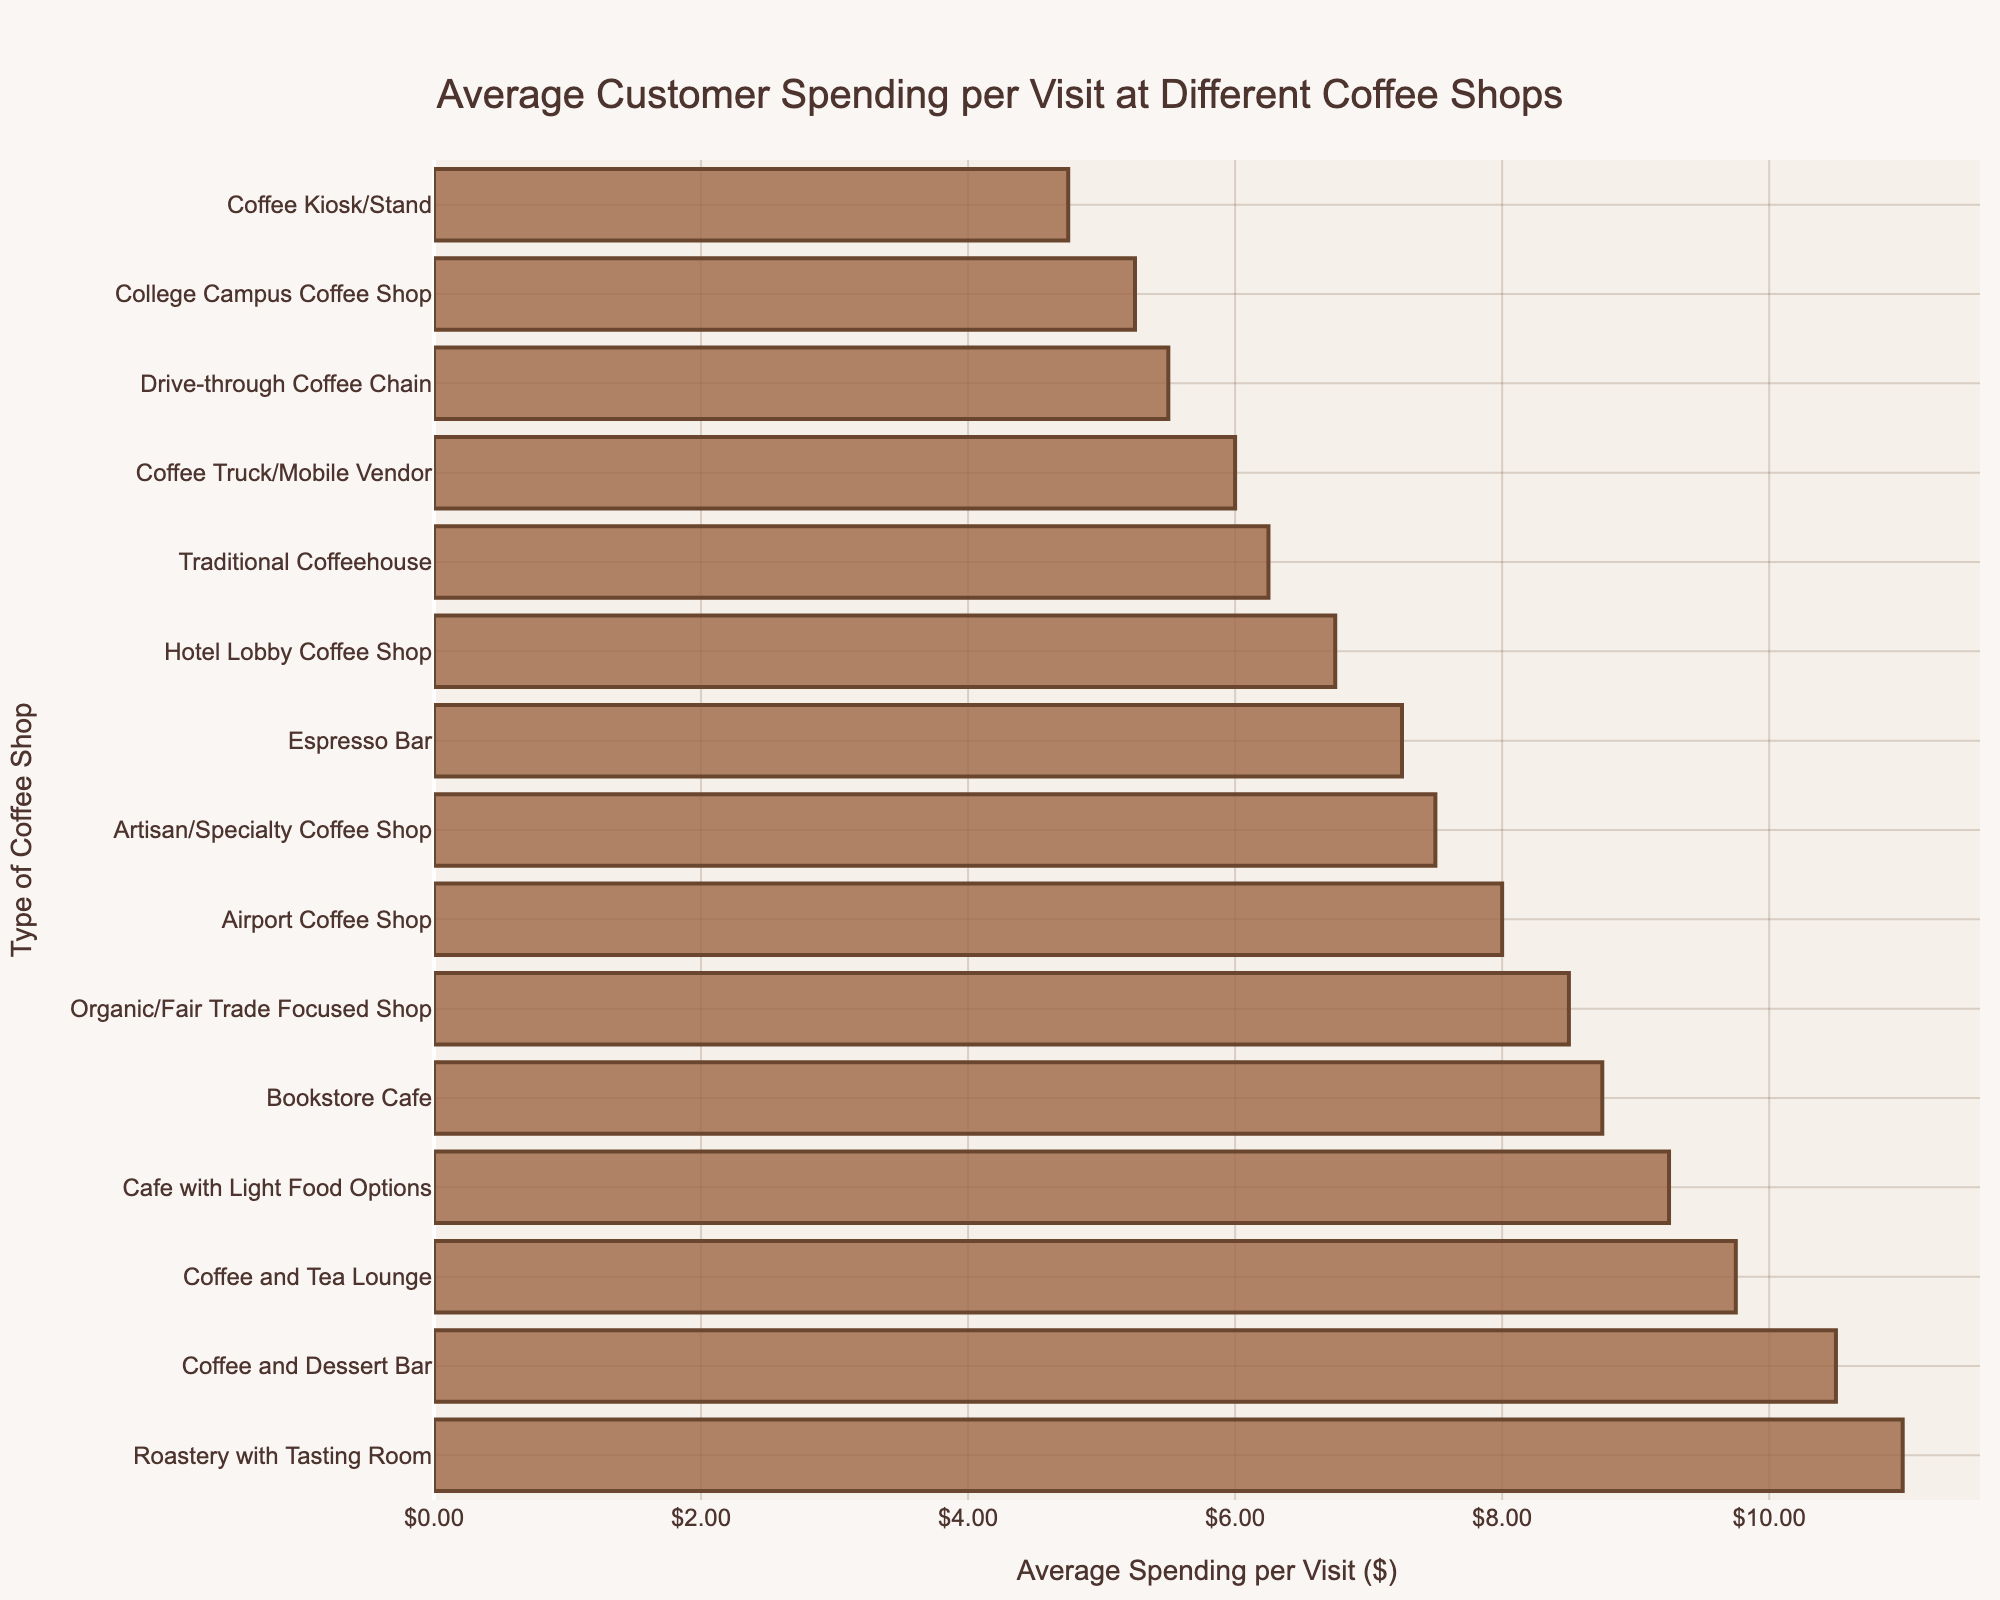What's the highest average customer spending per visit and at which type of coffee shop? The highest average spending per visit is $11.00 at a roastery with a tasting room. This is determined by looking at the bar with the longest length.
Answer: $11.00, Roastery with Tasting Room Which type of coffee shop has the lowest average customer spending per visit and what is the amount? The coffee kiosk/stand has the lowest average customer spending per visit at $4.75, which is identified by the shortest bar.
Answer: $4.75, Coffee Kiosk/Stand How much more does a customer spend on average at a coffee and dessert bar compared to a traditional coffeehouse? The average spending at a coffee and dessert bar is $10.50, while at a traditional coffeehouse it is $6.25. The difference is $10.50 - $6.25 = $4.25.
Answer: $4.25 What is the combined average spending of customers visiting the top three types of coffee shops? The top three types of coffee shops are roastery with tasting room ($11.00), coffee and dessert bar ($10.50), and coffee and tea lounge ($9.75). Their combined average spending is $11.00 + $10.50 + $9.75 = $31.25.
Answer: $31.25 Which coffee shop type has average spending closest to $8.00 and what is that spending? The airport coffee shop has an average spending of $8.00, as indicated by the bar that aligns exactly with the $8.00 mark on the x-axis.
Answer: $8.00, Airport Coffee Shop By how much does average spending at a college campus coffee shop differ from an organic/fair trade focused shop? The average spending at a college campus coffee shop is $5.25 and at an organic/fair trade focused shop is $8.50. The difference is $8.50 - $5.25 = $3.25.
Answer: $3.25 What is the median average customer spending per visit among all coffee shop types? To find the median, list all the spending values in ascending order and find the middle value or average the two middle values. The middle value in a list of 15 values is the 8th value. The sorted values are $4.75, $5.25, $5.50, $6.00, $6.25, $6.75, $7.25, $7.50, $8.00, $8.50, $8.75, $9.25, $9.75, $10.50, $11.00. The 8th value is $7.50.
Answer: $7.50 Which coffee shop types have average spending higher than the median value and what are those average spendings? The median average spending is $7.50. The coffee shop types with higher average spending are cafe with light food options ($9.25), bookstore cafe ($8.75), organic/fair trade focused shop ($8.50), coffee and dessert bar ($10.50), roastery with tasting room ($11.00), coffee and tea lounge ($9.75), airport coffee shop ($8.00).
Answer: Cafe with Light Food Options ($9.25), Bookstore Cafe ($8.75), Organic/Fair Trade Focused Shop ($8.50), Coffee and Dessert Bar ($10.50), Roastery with Tasting Room ($11.00), Coffee and Tea Lounge ($9.75), Airport Coffee Shop ($8.00) What is the range of average customer spendings among all coffee shop types? The range is the difference between the highest and lowest values. The highest value is $11.00 (Roastery with Tasting Room), and the lowest is $4.75 (Coffee Kiosk/Stand). So, the range is $11.00 - $4.75 = $6.25.
Answer: $6.25 On average, how much does a customer spend at a coffee shop offering light food options compared to an espresso bar? The average spending at a cafe with light food options is $9.25 and at an espresso bar is $7.25. The difference is $9.25 - $7.25 = $2.00.
Answer: $2.00 